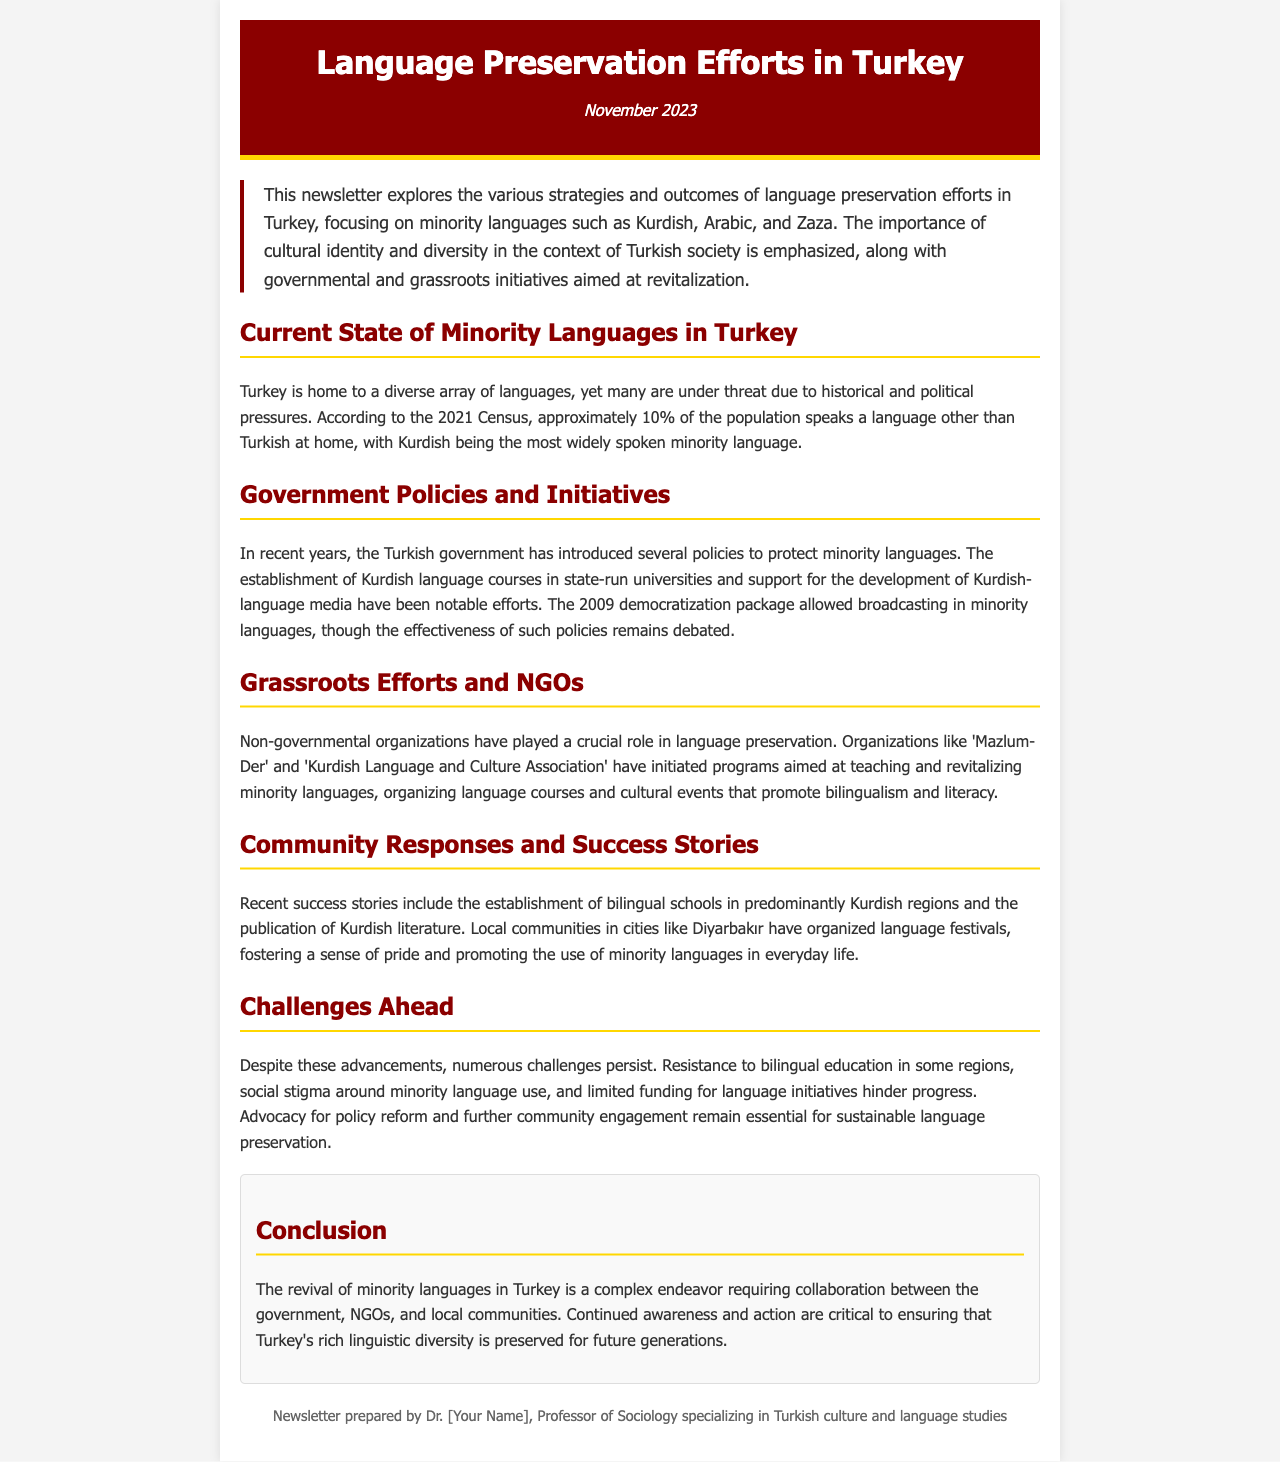what percentage of Turkey's population speaks a minority language at home? According to the 2021 Census, approximately 10% of the population speaks a language other than Turkish at home.
Answer: 10% which minority language is most widely spoken in Turkey? The document states that Kurdish is the most widely spoken minority language.
Answer: Kurdish what significant policy was introduced in 2009 to support minority languages? The 2009 democratization package allowed broadcasting in minority languages.
Answer: broadcasting in minority languages which organization is mentioned as a key player in language preservation? The document references 'Mazlum-Der' as a crucial organization for language preservation efforts.
Answer: Mazlum-Der what are local communities in cities like Diyarbakır organizing to promote minority languages? The document mentions that local communities are organizing language festivals to promote minority languages.
Answer: language festivals what is a major challenge to minority language preservation identified in the document? The document outlines that social stigma around minority language use is a significant challenge.
Answer: social stigma who prepared this newsletter? The footer states that the newsletter was prepared by Dr. [Your Name], a professor specializing in Turkish culture and language studies.
Answer: Dr. [Your Name] 